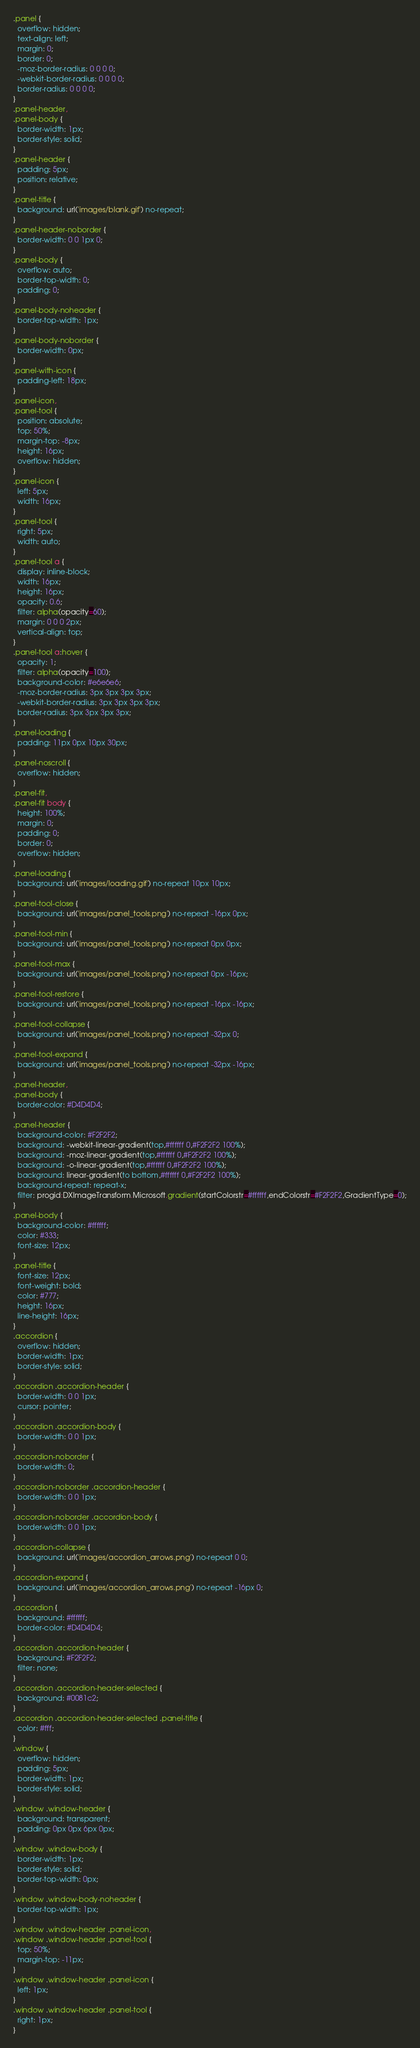<code> <loc_0><loc_0><loc_500><loc_500><_CSS_>.panel {
  overflow: hidden;
  text-align: left;
  margin: 0;
  border: 0;
  -moz-border-radius: 0 0 0 0;
  -webkit-border-radius: 0 0 0 0;
  border-radius: 0 0 0 0;
}
.panel-header,
.panel-body {
  border-width: 1px;
  border-style: solid;
}
.panel-header {
  padding: 5px;
  position: relative;
}
.panel-title {
  background: url('images/blank.gif') no-repeat;
}
.panel-header-noborder {
  border-width: 0 0 1px 0;
}
.panel-body {
  overflow: auto;
  border-top-width: 0;
  padding: 0;
}
.panel-body-noheader {
  border-top-width: 1px;
}
.panel-body-noborder {
  border-width: 0px;
}
.panel-with-icon {
  padding-left: 18px;
}
.panel-icon,
.panel-tool {
  position: absolute;
  top: 50%;
  margin-top: -8px;
  height: 16px;
  overflow: hidden;
}
.panel-icon {
  left: 5px;
  width: 16px;
}
.panel-tool {
  right: 5px;
  width: auto;
}
.panel-tool a {
  display: inline-block;
  width: 16px;
  height: 16px;
  opacity: 0.6;
  filter: alpha(opacity=60);
  margin: 0 0 0 2px;
  vertical-align: top;
}
.panel-tool a:hover {
  opacity: 1;
  filter: alpha(opacity=100);
  background-color: #e6e6e6;
  -moz-border-radius: 3px 3px 3px 3px;
  -webkit-border-radius: 3px 3px 3px 3px;
  border-radius: 3px 3px 3px 3px;
}
.panel-loading {
  padding: 11px 0px 10px 30px;
}
.panel-noscroll {
  overflow: hidden;
}
.panel-fit,
.panel-fit body {
  height: 100%;
  margin: 0;
  padding: 0;
  border: 0;
  overflow: hidden;
}
.panel-loading {
  background: url('images/loading.gif') no-repeat 10px 10px;
}
.panel-tool-close {
  background: url('images/panel_tools.png') no-repeat -16px 0px;
}
.panel-tool-min {
  background: url('images/panel_tools.png') no-repeat 0px 0px;
}
.panel-tool-max {
  background: url('images/panel_tools.png') no-repeat 0px -16px;
}
.panel-tool-restore {
  background: url('images/panel_tools.png') no-repeat -16px -16px;
}
.panel-tool-collapse {
  background: url('images/panel_tools.png') no-repeat -32px 0;
}
.panel-tool-expand {
  background: url('images/panel_tools.png') no-repeat -32px -16px;
}
.panel-header,
.panel-body {
  border-color: #D4D4D4;
}
.panel-header {
  background-color: #F2F2F2;
  background: -webkit-linear-gradient(top,#ffffff 0,#F2F2F2 100%);
  background: -moz-linear-gradient(top,#ffffff 0,#F2F2F2 100%);
  background: -o-linear-gradient(top,#ffffff 0,#F2F2F2 100%);
  background: linear-gradient(to bottom,#ffffff 0,#F2F2F2 100%);
  background-repeat: repeat-x;
  filter: progid:DXImageTransform.Microsoft.gradient(startColorstr=#ffffff,endColorstr=#F2F2F2,GradientType=0);
}
.panel-body {
  background-color: #ffffff;
  color: #333;
  font-size: 12px;
}
.panel-title {
  font-size: 12px;
  font-weight: bold;
  color: #777;
  height: 16px;
  line-height: 16px;
}
.accordion {
  overflow: hidden;
  border-width: 1px;
  border-style: solid;
}
.accordion .accordion-header {
  border-width: 0 0 1px;
  cursor: pointer;
}
.accordion .accordion-body {
  border-width: 0 0 1px;
}
.accordion-noborder {
  border-width: 0;
}
.accordion-noborder .accordion-header {
  border-width: 0 0 1px;
}
.accordion-noborder .accordion-body {
  border-width: 0 0 1px;
}
.accordion-collapse {
  background: url('images/accordion_arrows.png') no-repeat 0 0;
}
.accordion-expand {
  background: url('images/accordion_arrows.png') no-repeat -16px 0;
}
.accordion {
  background: #ffffff;
  border-color: #D4D4D4;
}
.accordion .accordion-header {
  background: #F2F2F2;
  filter: none;
}
.accordion .accordion-header-selected {
  background: #0081c2;
}
.accordion .accordion-header-selected .panel-title {
  color: #fff;
}
.window {
  overflow: hidden;
  padding: 5px;
  border-width: 1px;
  border-style: solid;
}
.window .window-header {
  background: transparent;
  padding: 0px 0px 6px 0px;
}
.window .window-body {
  border-width: 1px;
  border-style: solid;
  border-top-width: 0px;
}
.window .window-body-noheader {
  border-top-width: 1px;
}
.window .window-header .panel-icon,
.window .window-header .panel-tool {
  top: 50%;
  margin-top: -11px;
}
.window .window-header .panel-icon {
  left: 1px;
}
.window .window-header .panel-tool {
  right: 1px;
}</code> 